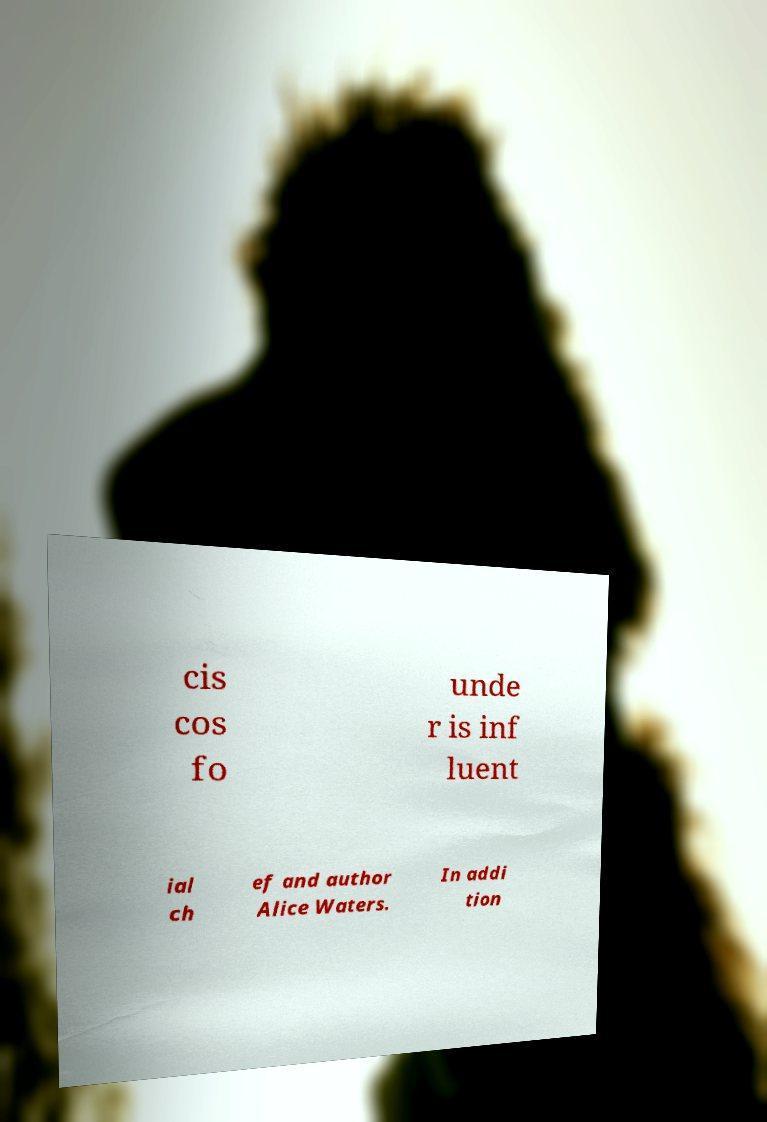Can you accurately transcribe the text from the provided image for me? cis cos fo unde r is inf luent ial ch ef and author Alice Waters. In addi tion 